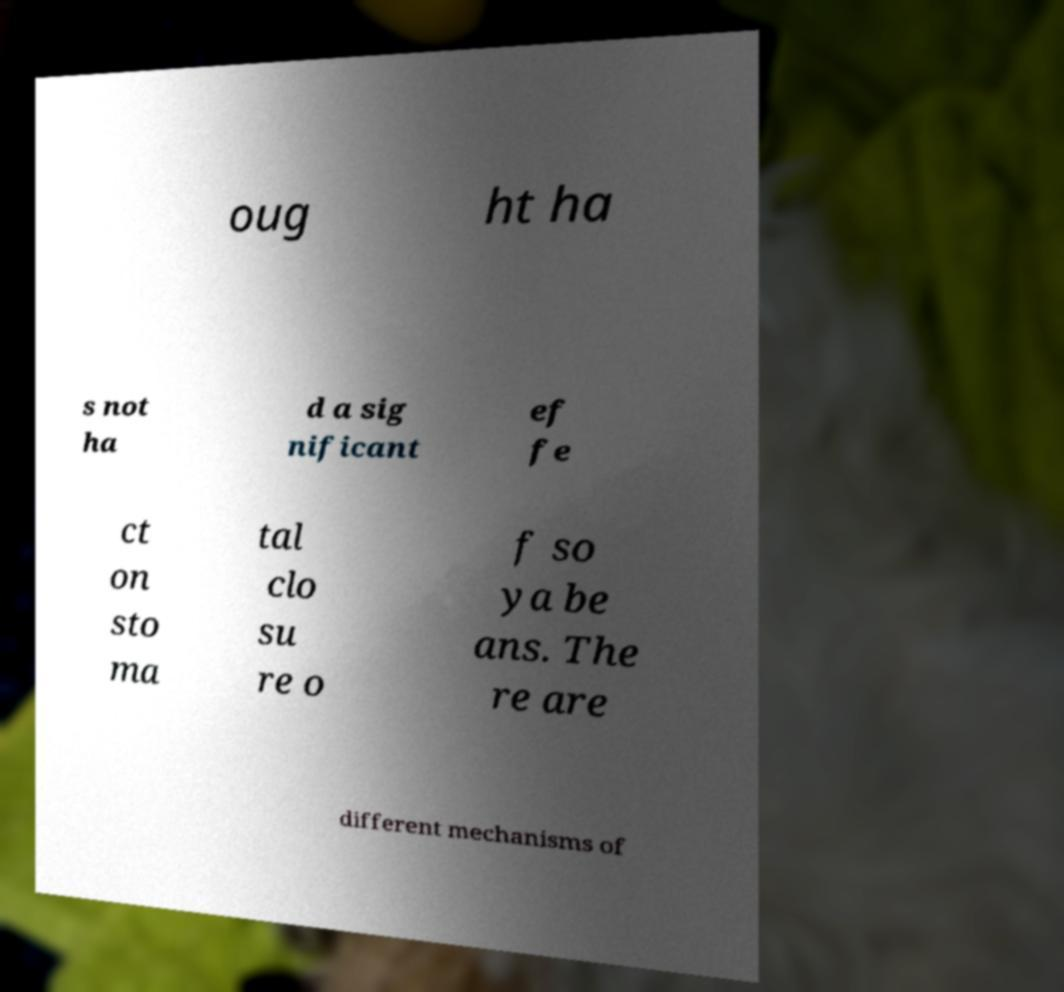I need the written content from this picture converted into text. Can you do that? oug ht ha s not ha d a sig nificant ef fe ct on sto ma tal clo su re o f so ya be ans. The re are different mechanisms of 